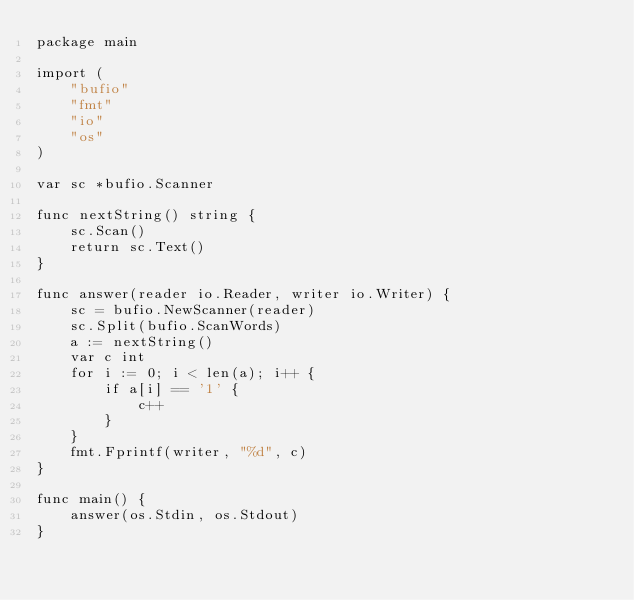Convert code to text. <code><loc_0><loc_0><loc_500><loc_500><_Go_>package main

import (
	"bufio"
	"fmt"
	"io"
	"os"
)

var sc *bufio.Scanner

func nextString() string {
	sc.Scan()
	return sc.Text()
}

func answer(reader io.Reader, writer io.Writer) {
	sc = bufio.NewScanner(reader)
	sc.Split(bufio.ScanWords)
	a := nextString()
	var c int
	for i := 0; i < len(a); i++ {
		if a[i] == '1' {
			c++
		}
	}
	fmt.Fprintf(writer, "%d", c)
}

func main() {
	answer(os.Stdin, os.Stdout)
}
</code> 